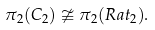Convert formula to latex. <formula><loc_0><loc_0><loc_500><loc_500>\pi _ { 2 } ( C _ { 2 } ) \ncong \pi _ { 2 } ( R a t _ { 2 } ) .</formula> 